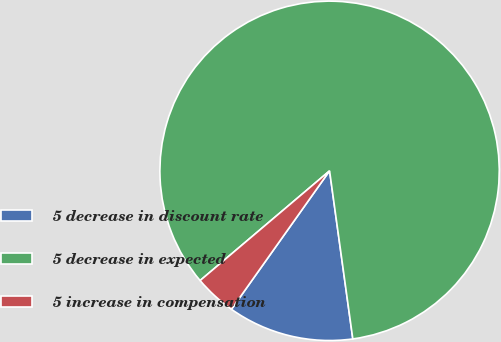Convert chart to OTSL. <chart><loc_0><loc_0><loc_500><loc_500><pie_chart><fcel>5 decrease in discount rate<fcel>5 decrease in expected<fcel>5 increase in compensation<nl><fcel>12.0%<fcel>84.0%<fcel>4.0%<nl></chart> 